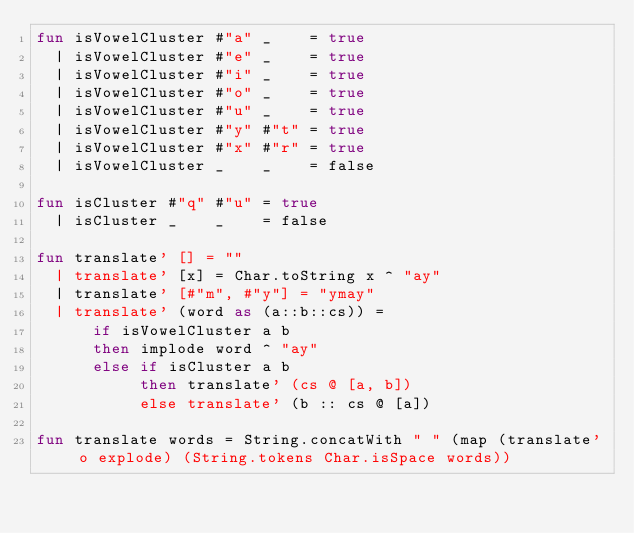Convert code to text. <code><loc_0><loc_0><loc_500><loc_500><_SML_>fun isVowelCluster #"a" _    = true
  | isVowelCluster #"e" _    = true
  | isVowelCluster #"i" _    = true
  | isVowelCluster #"o" _    = true
  | isVowelCluster #"u" _    = true
  | isVowelCluster #"y" #"t" = true
  | isVowelCluster #"x" #"r" = true
  | isVowelCluster _    _    = false

fun isCluster #"q" #"u" = true
  | isCluster _    _    = false

fun translate' [] = ""
  | translate' [x] = Char.toString x ^ "ay"
  | translate' [#"m", #"y"] = "ymay"
  | translate' (word as (a::b::cs)) =
      if isVowelCluster a b
      then implode word ^ "ay"
      else if isCluster a b
           then translate' (cs @ [a, b])
           else translate' (b :: cs @ [a])

fun translate words = String.concatWith " " (map (translate' o explode) (String.tokens Char.isSpace words))
</code> 